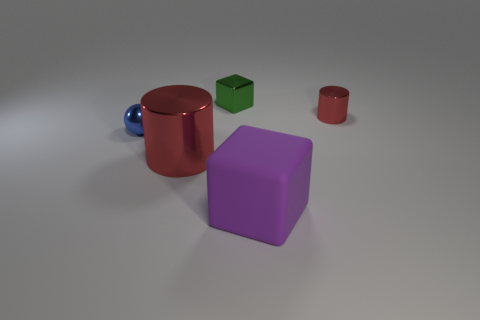Add 1 green blocks. How many objects exist? 6 Subtract all cylinders. How many objects are left? 3 Add 5 big purple blocks. How many big purple blocks are left? 6 Add 5 small green matte spheres. How many small green matte spheres exist? 5 Subtract 0 green balls. How many objects are left? 5 Subtract all spheres. Subtract all large red things. How many objects are left? 3 